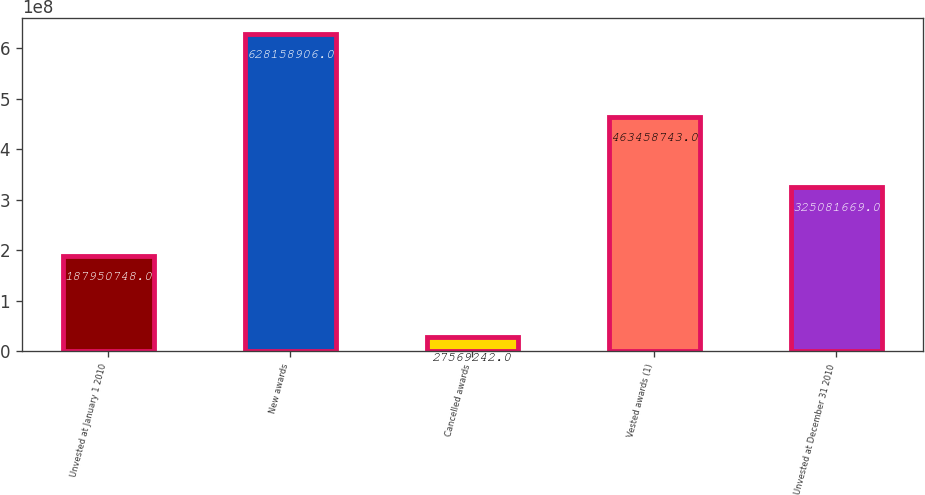Convert chart to OTSL. <chart><loc_0><loc_0><loc_500><loc_500><bar_chart><fcel>Unvested at January 1 2010<fcel>New awards<fcel>Cancelled awards<fcel>Vested awards (1)<fcel>Unvested at December 31 2010<nl><fcel>1.87951e+08<fcel>6.28159e+08<fcel>2.75692e+07<fcel>4.63459e+08<fcel>3.25082e+08<nl></chart> 